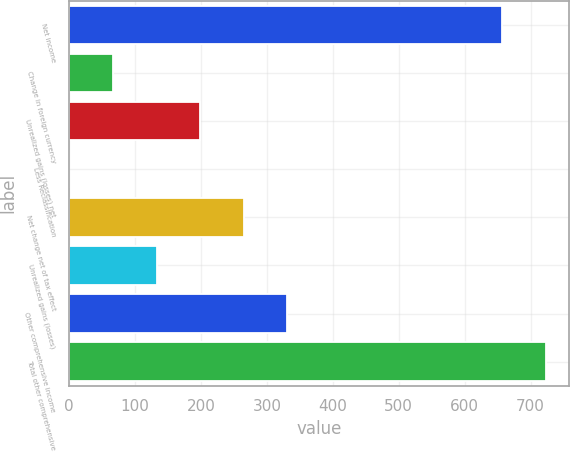Convert chart to OTSL. <chart><loc_0><loc_0><loc_500><loc_500><bar_chart><fcel>Net income<fcel>Change in foreign currency<fcel>Unrealized gains (losses) net<fcel>Less Reclassification<fcel>Net change net of tax effect<fcel>Unrealized gains (losses)<fcel>Other comprehensive income<fcel>Total other comprehensive<nl><fcel>656.6<fcel>66.32<fcel>198.76<fcel>0.1<fcel>264.98<fcel>132.54<fcel>331.2<fcel>722.82<nl></chart> 